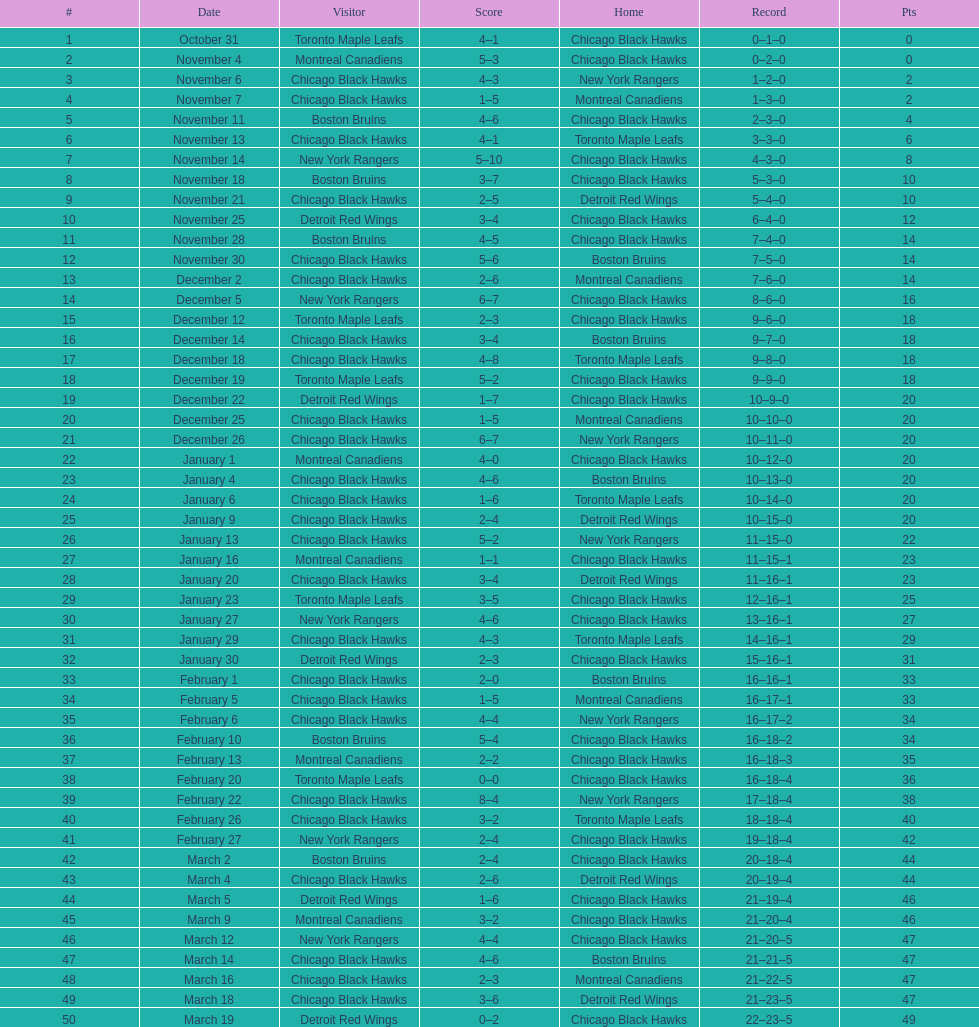What is was the difference in score in the december 19th win? 3. 